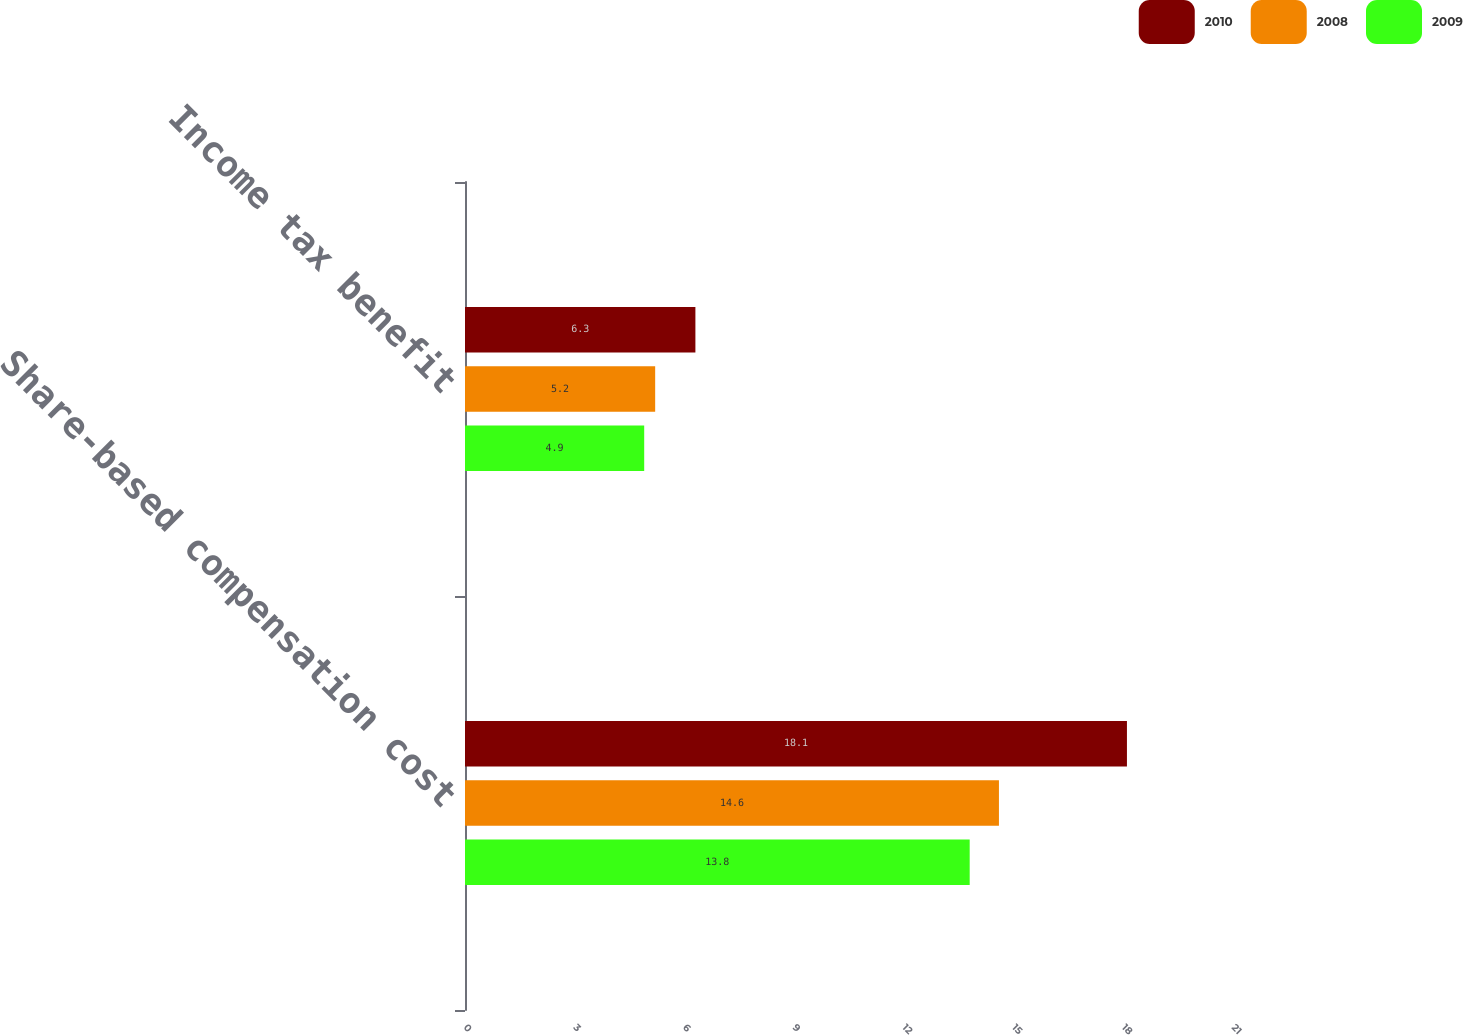Convert chart. <chart><loc_0><loc_0><loc_500><loc_500><stacked_bar_chart><ecel><fcel>Share-based compensation cost<fcel>Income tax benefit<nl><fcel>2010<fcel>18.1<fcel>6.3<nl><fcel>2008<fcel>14.6<fcel>5.2<nl><fcel>2009<fcel>13.8<fcel>4.9<nl></chart> 